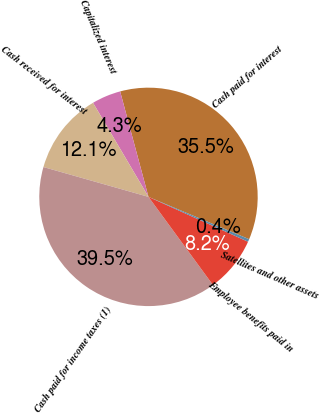Convert chart to OTSL. <chart><loc_0><loc_0><loc_500><loc_500><pie_chart><fcel>Cash paid for interest<fcel>Capitalized interest<fcel>Cash received for interest<fcel>Cash paid for income taxes (1)<fcel>Employee benefits paid in<fcel>Satellites and other assets<nl><fcel>35.52%<fcel>4.3%<fcel>12.12%<fcel>39.46%<fcel>8.21%<fcel>0.4%<nl></chart> 